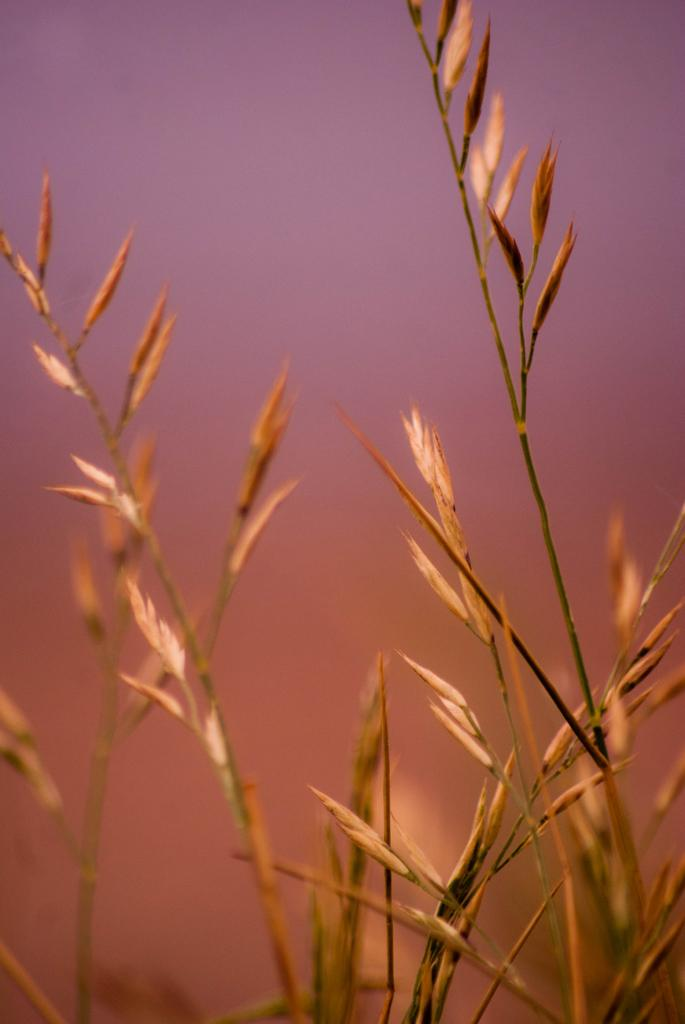What type of living organisms can be seen in the image? Plants can be seen in the image. Where are the plants located in the image? The plants are located towards the bottom of the image. What can be seen in the background of the image? The sky is visible in the background of the image. What type of neck accessory is being worn by the plants in the image? There are no neck accessories present in the image, as the main subject is plants. 